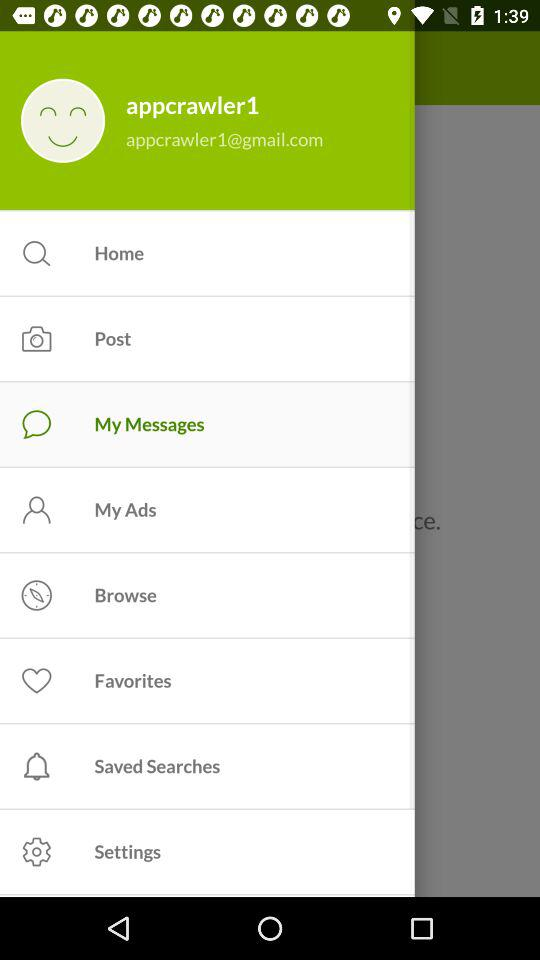What is the name of the user? The name of the user is appcrawler1. 